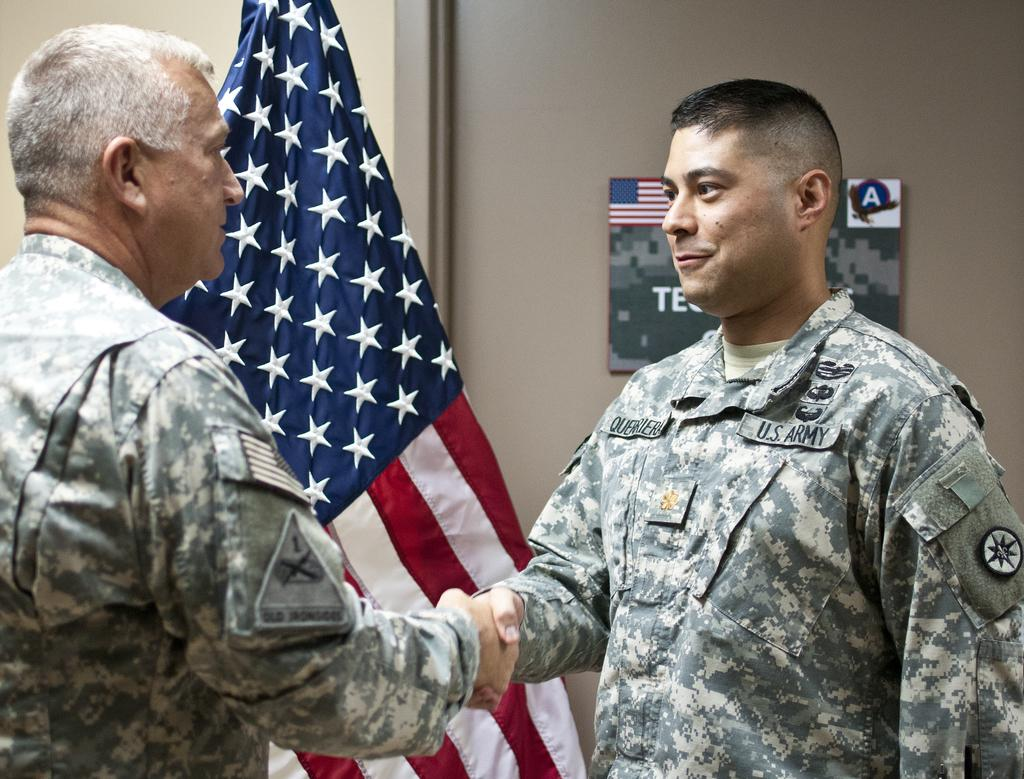How many people are in the image? There are two men in the image. What are the men doing in the image? The men are shaking hands. What can be seen in the background of the image? There is a wall with a frame in the background. What is the additional element present in the image? There is a flag in the image. How many boats are visible in the image? There are no boats present in the image. What type of help can be provided by the earth in the image? There is no reference to the earth or any help in the image. 